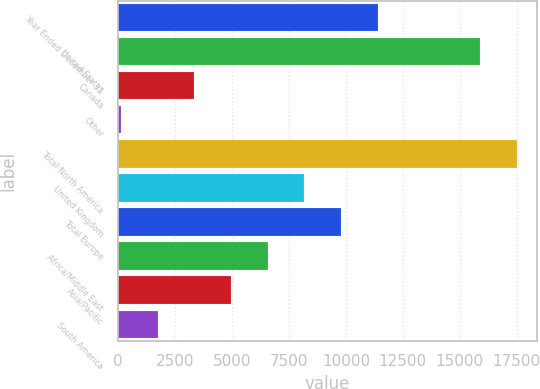<chart> <loc_0><loc_0><loc_500><loc_500><bar_chart><fcel>Year Ended December 31<fcel>United States<fcel>Canada<fcel>Other<fcel>Total North America<fcel>United Kingdom<fcel>Total Europe<fcel>Africa/Middle East<fcel>Asia/Pacific<fcel>South America<nl><fcel>11399.7<fcel>15882<fcel>3344.2<fcel>122<fcel>17493.1<fcel>8177.5<fcel>9788.6<fcel>6566.4<fcel>4955.3<fcel>1733.1<nl></chart> 